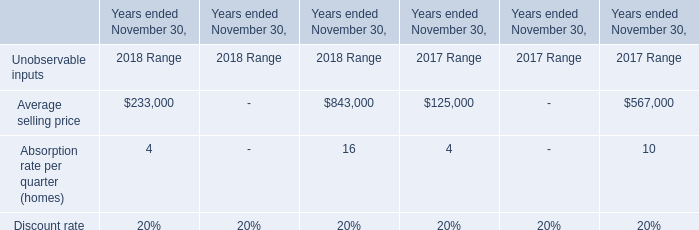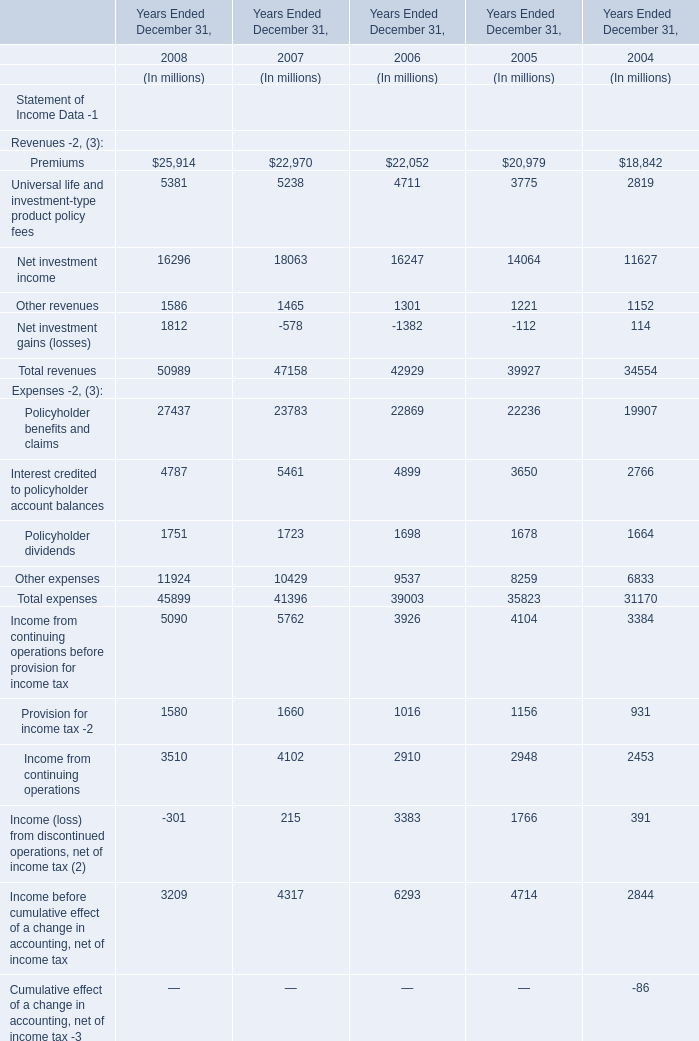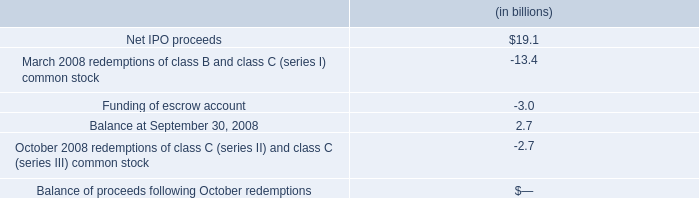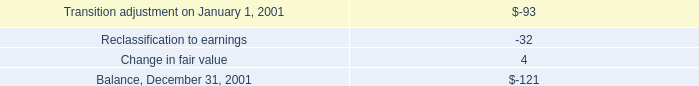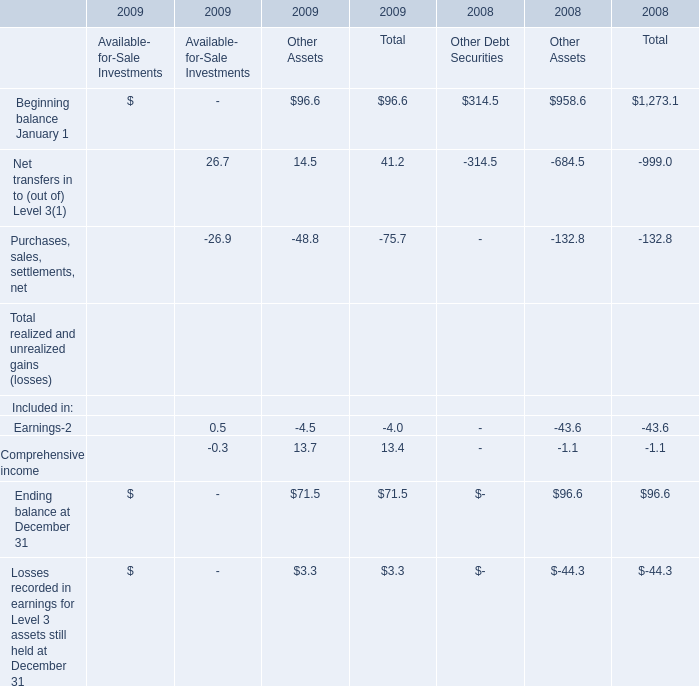What is the growing rate of Ending balance in the year with the most Comprehensive income? 
Computations: ((71.5 - 96.6) / 96.6)
Answer: -0.25983. 